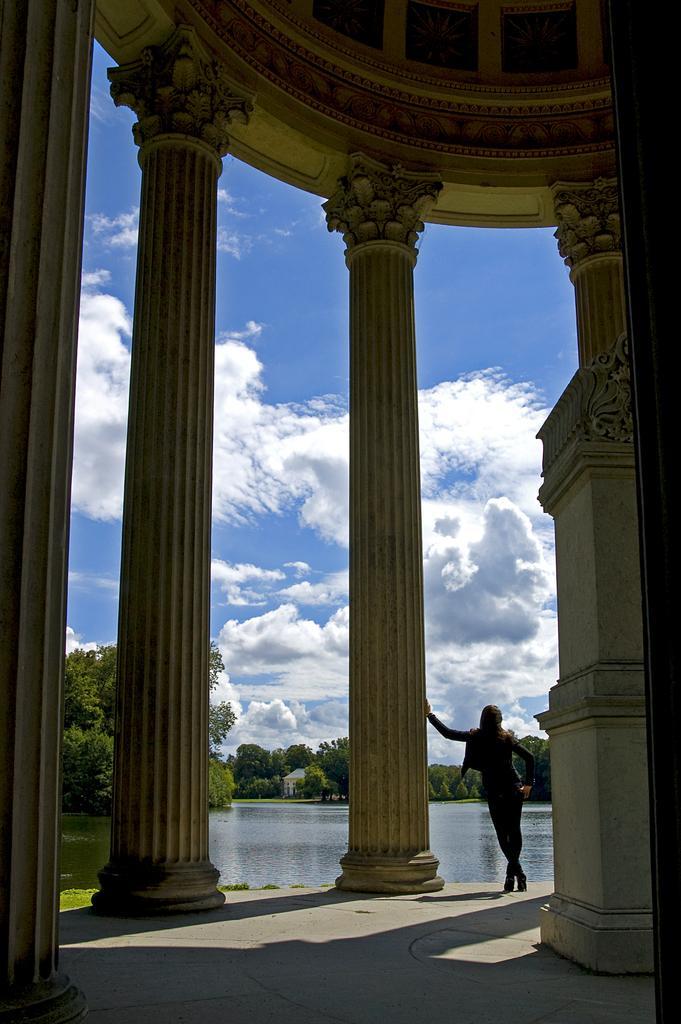Please provide a concise description of this image. In this image, there is a person standing and wearing clothes. There is a lake at the bottom of the image. There are pillars and sky in the middle of the image. 